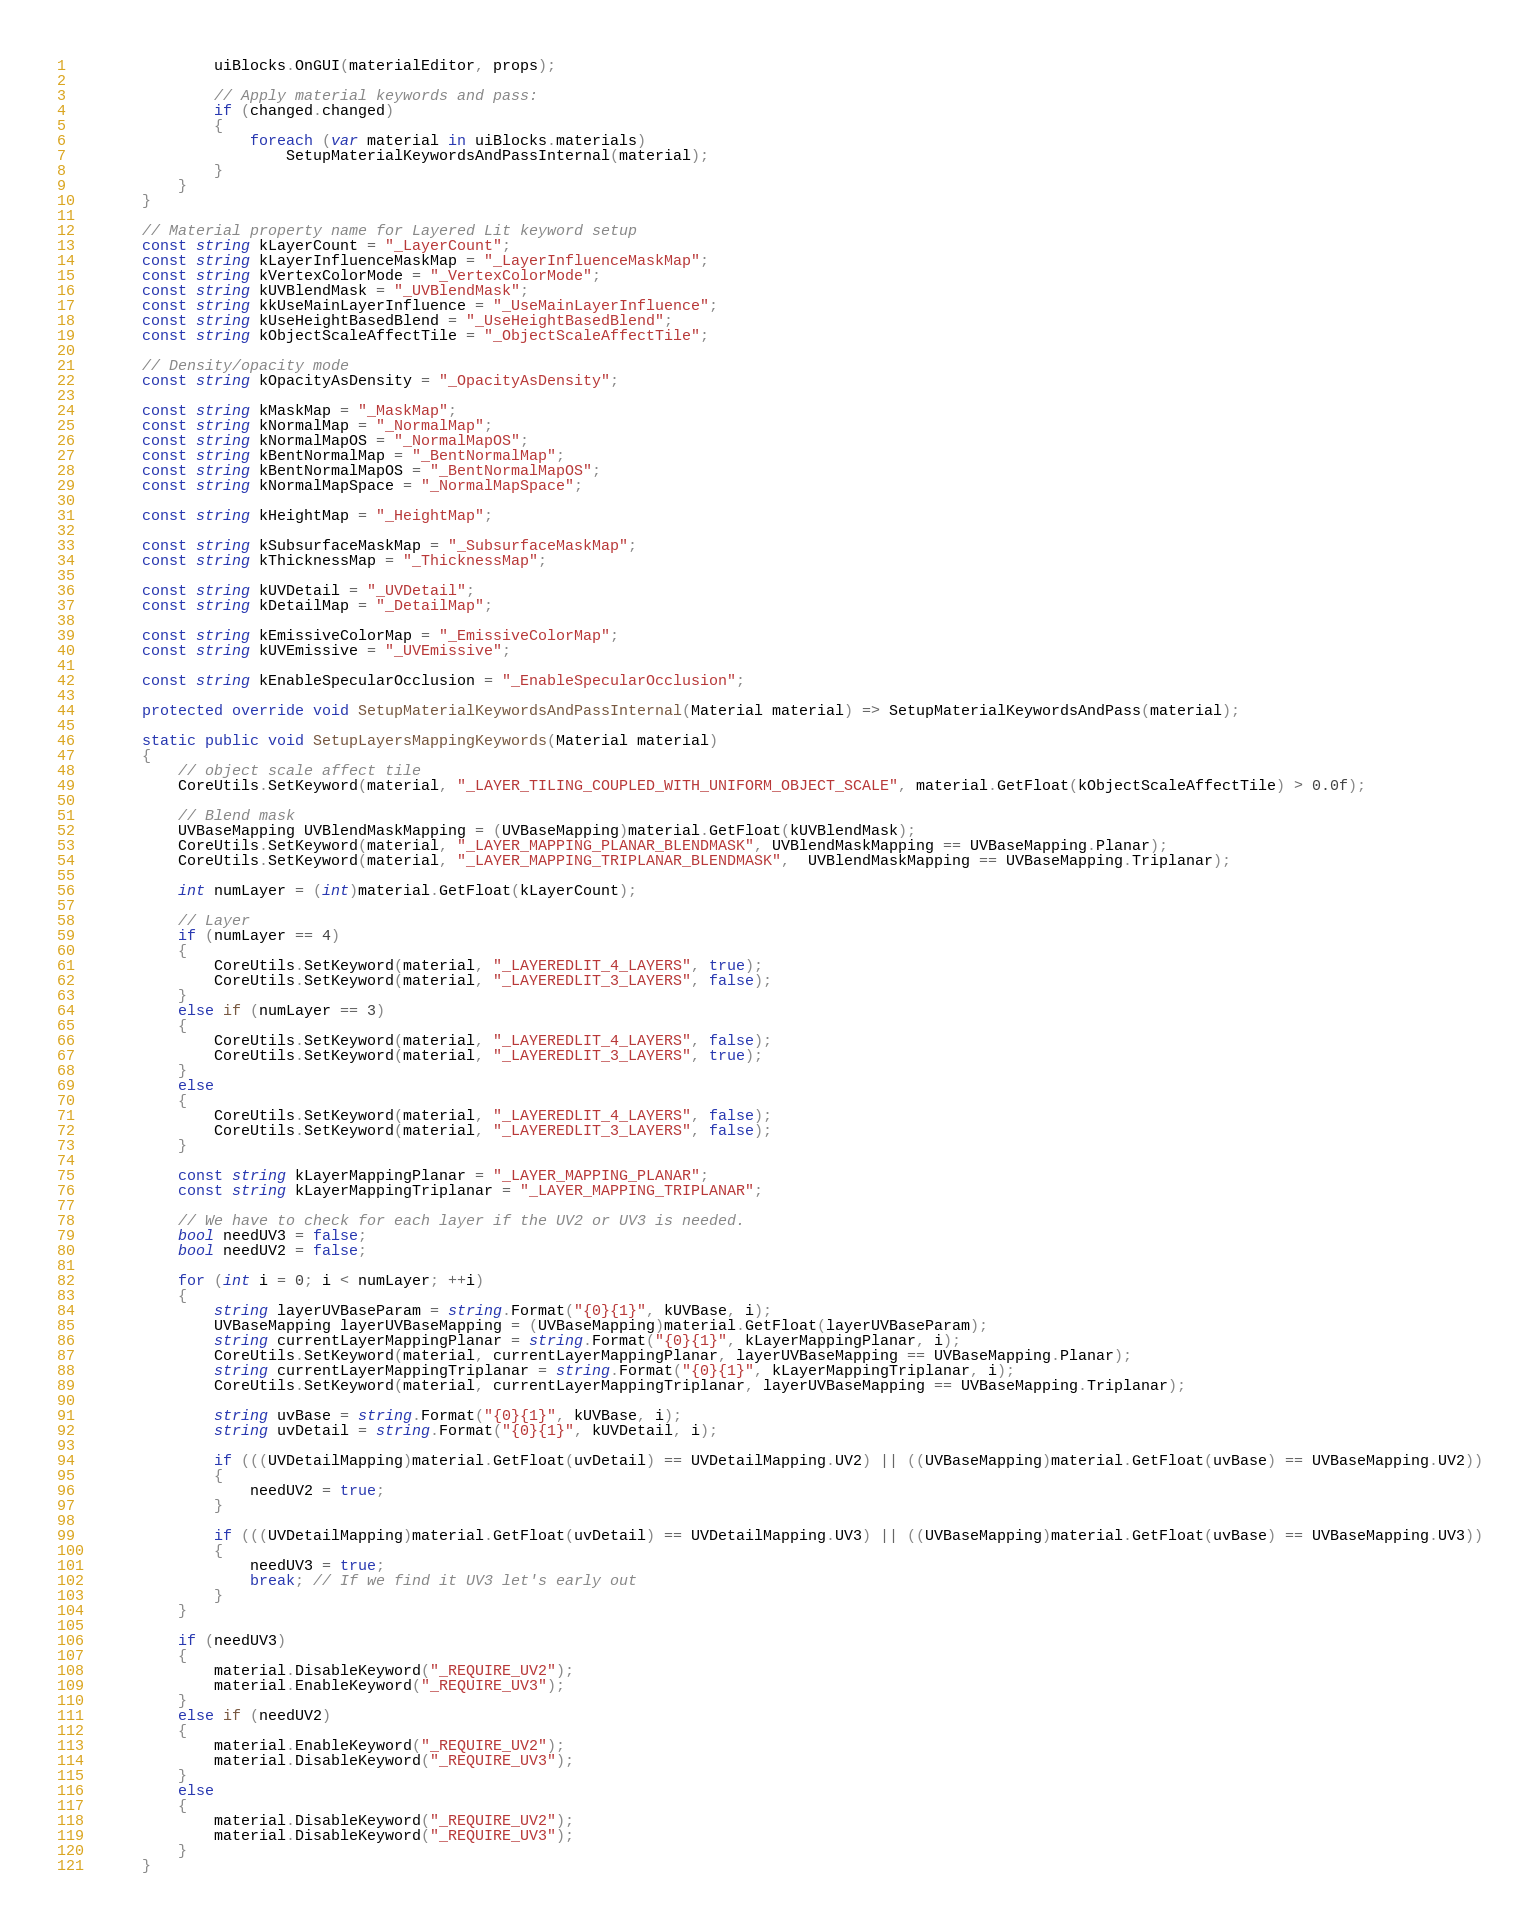<code> <loc_0><loc_0><loc_500><loc_500><_C#_>                uiBlocks.OnGUI(materialEditor, props);

                // Apply material keywords and pass:
                if (changed.changed)
                {
                    foreach (var material in uiBlocks.materials)
                        SetupMaterialKeywordsAndPassInternal(material);
                }
            }
        }

        // Material property name for Layered Lit keyword setup
        const string kLayerCount = "_LayerCount";
        const string kLayerInfluenceMaskMap = "_LayerInfluenceMaskMap";
        const string kVertexColorMode = "_VertexColorMode";
        const string kUVBlendMask = "_UVBlendMask";
        const string kkUseMainLayerInfluence = "_UseMainLayerInfluence";
        const string kUseHeightBasedBlend = "_UseHeightBasedBlend";
        const string kObjectScaleAffectTile = "_ObjectScaleAffectTile";

        // Density/opacity mode
        const string kOpacityAsDensity = "_OpacityAsDensity";

        const string kMaskMap = "_MaskMap";
        const string kNormalMap = "_NormalMap";
        const string kNormalMapOS = "_NormalMapOS";
        const string kBentNormalMap = "_BentNormalMap";
        const string kBentNormalMapOS = "_BentNormalMapOS";
        const string kNormalMapSpace = "_NormalMapSpace";

        const string kHeightMap = "_HeightMap";

        const string kSubsurfaceMaskMap = "_SubsurfaceMaskMap";
        const string kThicknessMap = "_ThicknessMap";

        const string kUVDetail = "_UVDetail";
        const string kDetailMap = "_DetailMap";

        const string kEmissiveColorMap = "_EmissiveColorMap";
        const string kUVEmissive = "_UVEmissive";

        const string kEnableSpecularOcclusion = "_EnableSpecularOcclusion";

        protected override void SetupMaterialKeywordsAndPassInternal(Material material) => SetupMaterialKeywordsAndPass(material);

        static public void SetupLayersMappingKeywords(Material material)
        {
            // object scale affect tile
            CoreUtils.SetKeyword(material, "_LAYER_TILING_COUPLED_WITH_UNIFORM_OBJECT_SCALE", material.GetFloat(kObjectScaleAffectTile) > 0.0f);

            // Blend mask
            UVBaseMapping UVBlendMaskMapping = (UVBaseMapping)material.GetFloat(kUVBlendMask);
            CoreUtils.SetKeyword(material, "_LAYER_MAPPING_PLANAR_BLENDMASK", UVBlendMaskMapping == UVBaseMapping.Planar);
            CoreUtils.SetKeyword(material, "_LAYER_MAPPING_TRIPLANAR_BLENDMASK",  UVBlendMaskMapping == UVBaseMapping.Triplanar);

            int numLayer = (int)material.GetFloat(kLayerCount);

            // Layer
            if (numLayer == 4)
            {
                CoreUtils.SetKeyword(material, "_LAYEREDLIT_4_LAYERS", true);
                CoreUtils.SetKeyword(material, "_LAYEREDLIT_3_LAYERS", false);
            }
            else if (numLayer == 3)
            {
                CoreUtils.SetKeyword(material, "_LAYEREDLIT_4_LAYERS", false);
                CoreUtils.SetKeyword(material, "_LAYEREDLIT_3_LAYERS", true);
            }
            else
            {
                CoreUtils.SetKeyword(material, "_LAYEREDLIT_4_LAYERS", false);
                CoreUtils.SetKeyword(material, "_LAYEREDLIT_3_LAYERS", false);
            }

            const string kLayerMappingPlanar = "_LAYER_MAPPING_PLANAR";
            const string kLayerMappingTriplanar = "_LAYER_MAPPING_TRIPLANAR";

            // We have to check for each layer if the UV2 or UV3 is needed.
            bool needUV3 = false;
            bool needUV2 = false;

            for (int i = 0; i < numLayer; ++i)
            {
                string layerUVBaseParam = string.Format("{0}{1}", kUVBase, i);
                UVBaseMapping layerUVBaseMapping = (UVBaseMapping)material.GetFloat(layerUVBaseParam);
                string currentLayerMappingPlanar = string.Format("{0}{1}", kLayerMappingPlanar, i);
                CoreUtils.SetKeyword(material, currentLayerMappingPlanar, layerUVBaseMapping == UVBaseMapping.Planar);
                string currentLayerMappingTriplanar = string.Format("{0}{1}", kLayerMappingTriplanar, i);
                CoreUtils.SetKeyword(material, currentLayerMappingTriplanar, layerUVBaseMapping == UVBaseMapping.Triplanar);

                string uvBase = string.Format("{0}{1}", kUVBase, i);
                string uvDetail = string.Format("{0}{1}", kUVDetail, i);

                if (((UVDetailMapping)material.GetFloat(uvDetail) == UVDetailMapping.UV2) || ((UVBaseMapping)material.GetFloat(uvBase) == UVBaseMapping.UV2))
                {
                    needUV2 = true;
                }

                if (((UVDetailMapping)material.GetFloat(uvDetail) == UVDetailMapping.UV3) || ((UVBaseMapping)material.GetFloat(uvBase) == UVBaseMapping.UV3))
                {
                    needUV3 = true;
                    break; // If we find it UV3 let's early out
                }
            }

            if (needUV3)
            {
                material.DisableKeyword("_REQUIRE_UV2");
                material.EnableKeyword("_REQUIRE_UV3");
            }
            else if (needUV2)
            {
                material.EnableKeyword("_REQUIRE_UV2");
                material.DisableKeyword("_REQUIRE_UV3");
            }
            else
            {
                material.DisableKeyword("_REQUIRE_UV2");
                material.DisableKeyword("_REQUIRE_UV3");
            }
        }
</code> 